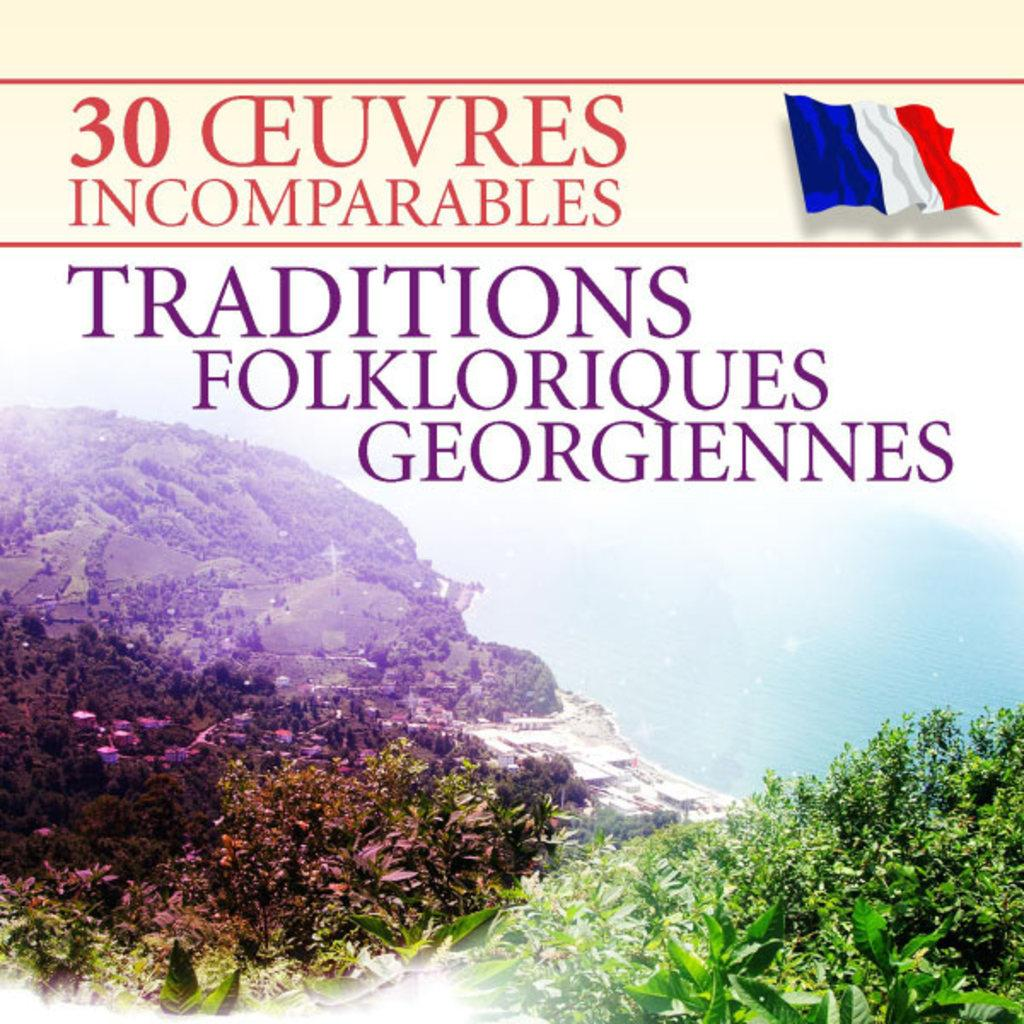<image>
Present a compact description of the photo's key features. A cover with a French flag has a title that begins with traditions. 